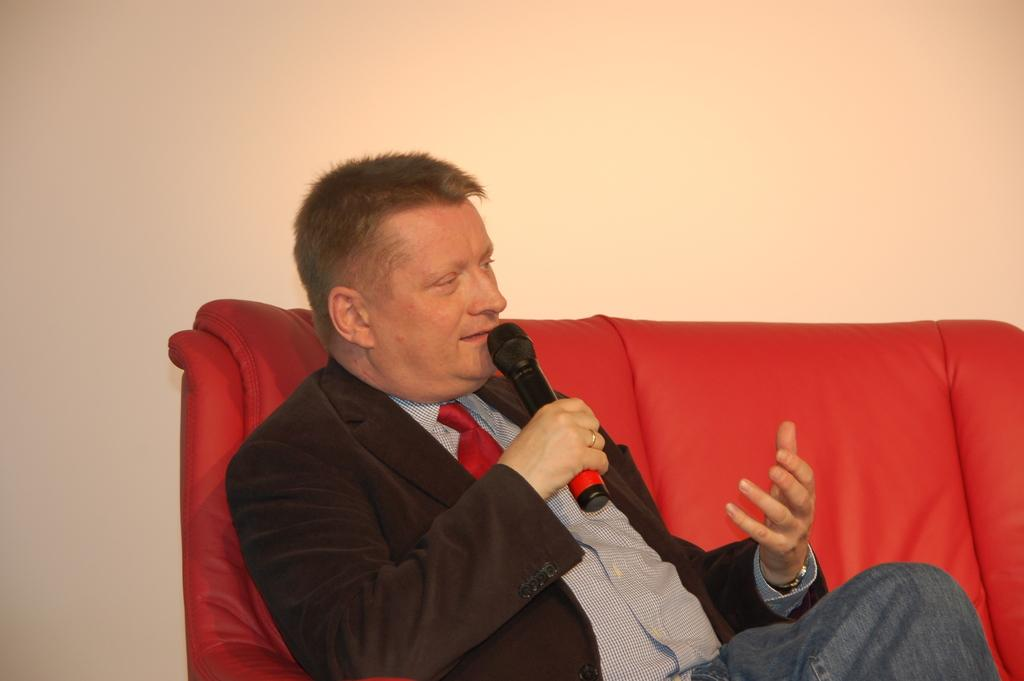What is the person in the image sitting on? The person is sitting on a red sofa. What is the person holding in his hand? The person is holding a microphone in his hand. What type of clothing is the person wearing on top? The person is wearing a black suit. What type of clothing is the person wearing on the bottom? The person is wearing jeans. Can you see any goldfish swimming in the background of the image? There are no goldfish present in the image. 